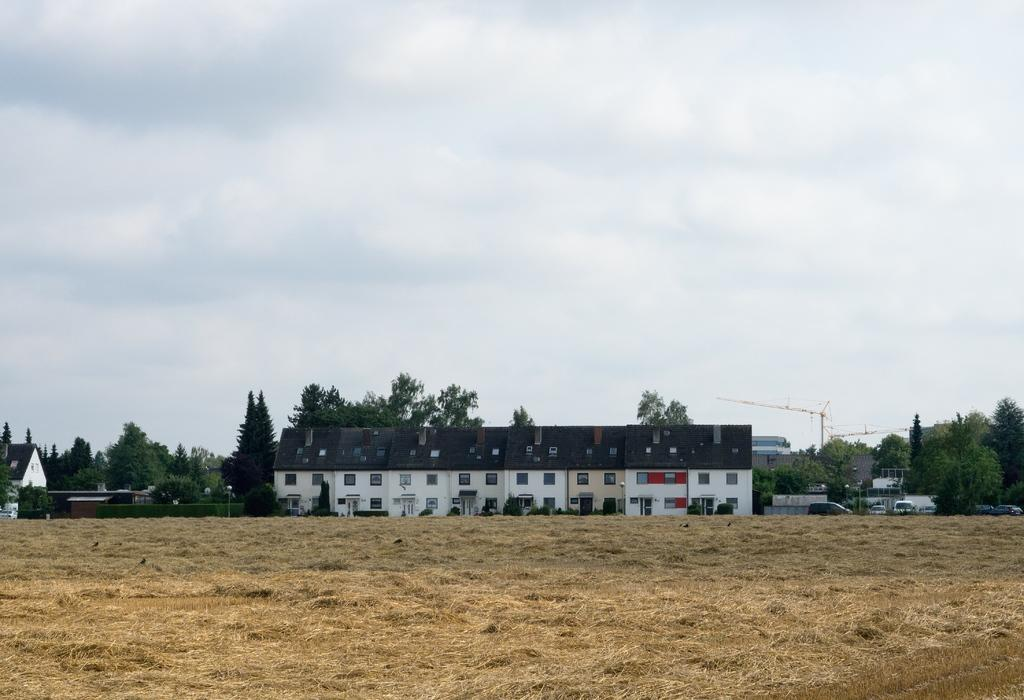What type of structures can be seen in the image? There are buildings with windows in the image. What is the ground covered with in the image? There is dried grass in the image. What type of transportation is visible in the image? Vehicles are visible in the image. What type of vegetation is present in the image? Trees and bushes are present in the image. What is being used for construction in the image? There is a tower crane in the image. What part of the natural environment is visible in the image? The sky is visible in the image. What type of fact can be seen being protested by a group of people in the image? There is no protest or fact present in the image; it features buildings, dried grass, vehicles, trees, bushes, a tower crane, and the sky. What type of shirt is being worn by the person holding the protest sign in the image? There is no person holding a protest sign or wearing a shirt in the image. 